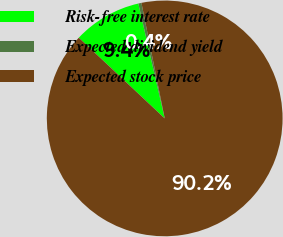<chart> <loc_0><loc_0><loc_500><loc_500><pie_chart><fcel>Risk-free interest rate<fcel>Expected dividend yield<fcel>Expected stock price<nl><fcel>9.4%<fcel>0.43%<fcel>90.16%<nl></chart> 